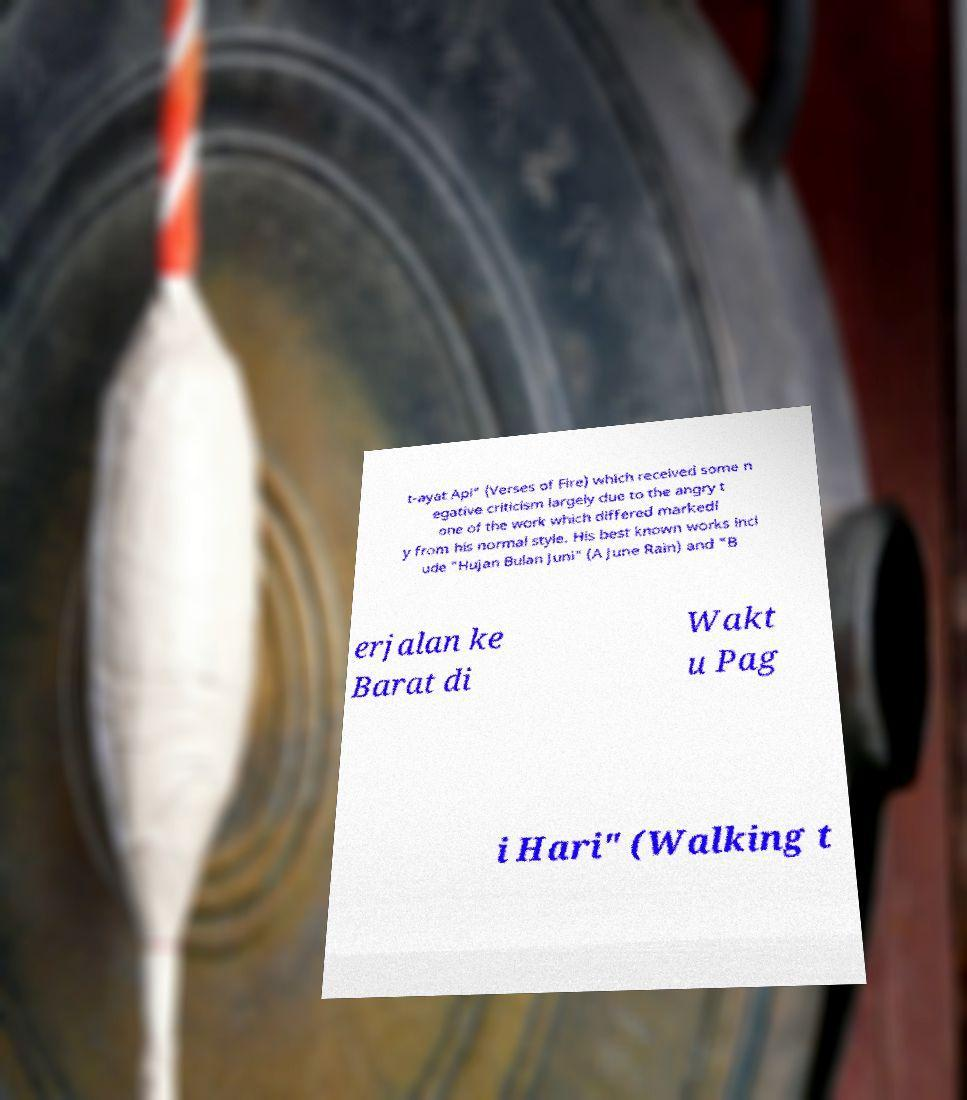Can you accurately transcribe the text from the provided image for me? t-ayat Api" (Verses of Fire) which received some n egative criticism largely due to the angry t one of the work which differed markedl y from his normal style. His best known works incl ude "Hujan Bulan Juni" (A June Rain) and "B erjalan ke Barat di Wakt u Pag i Hari" (Walking t 